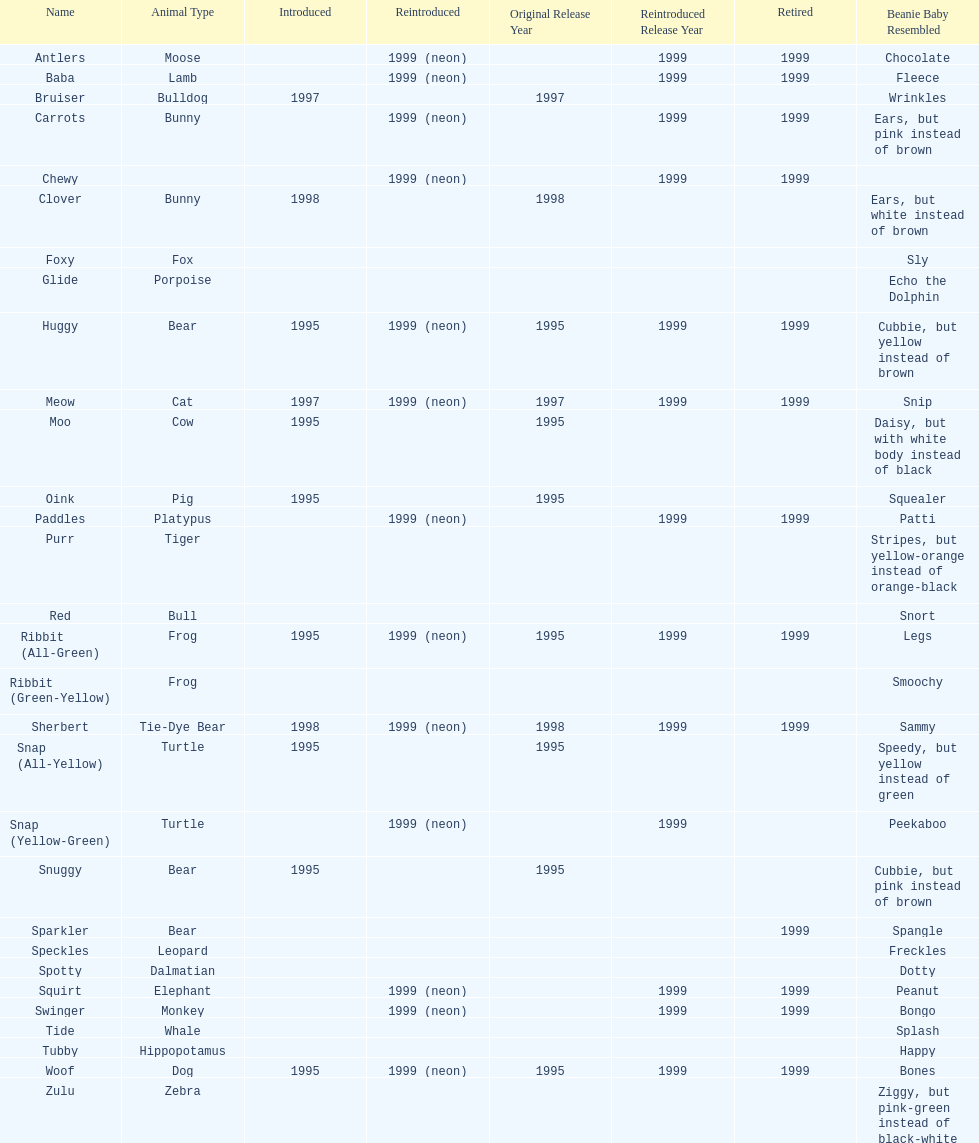In what year were the first pillow pals introduced? 1995. 